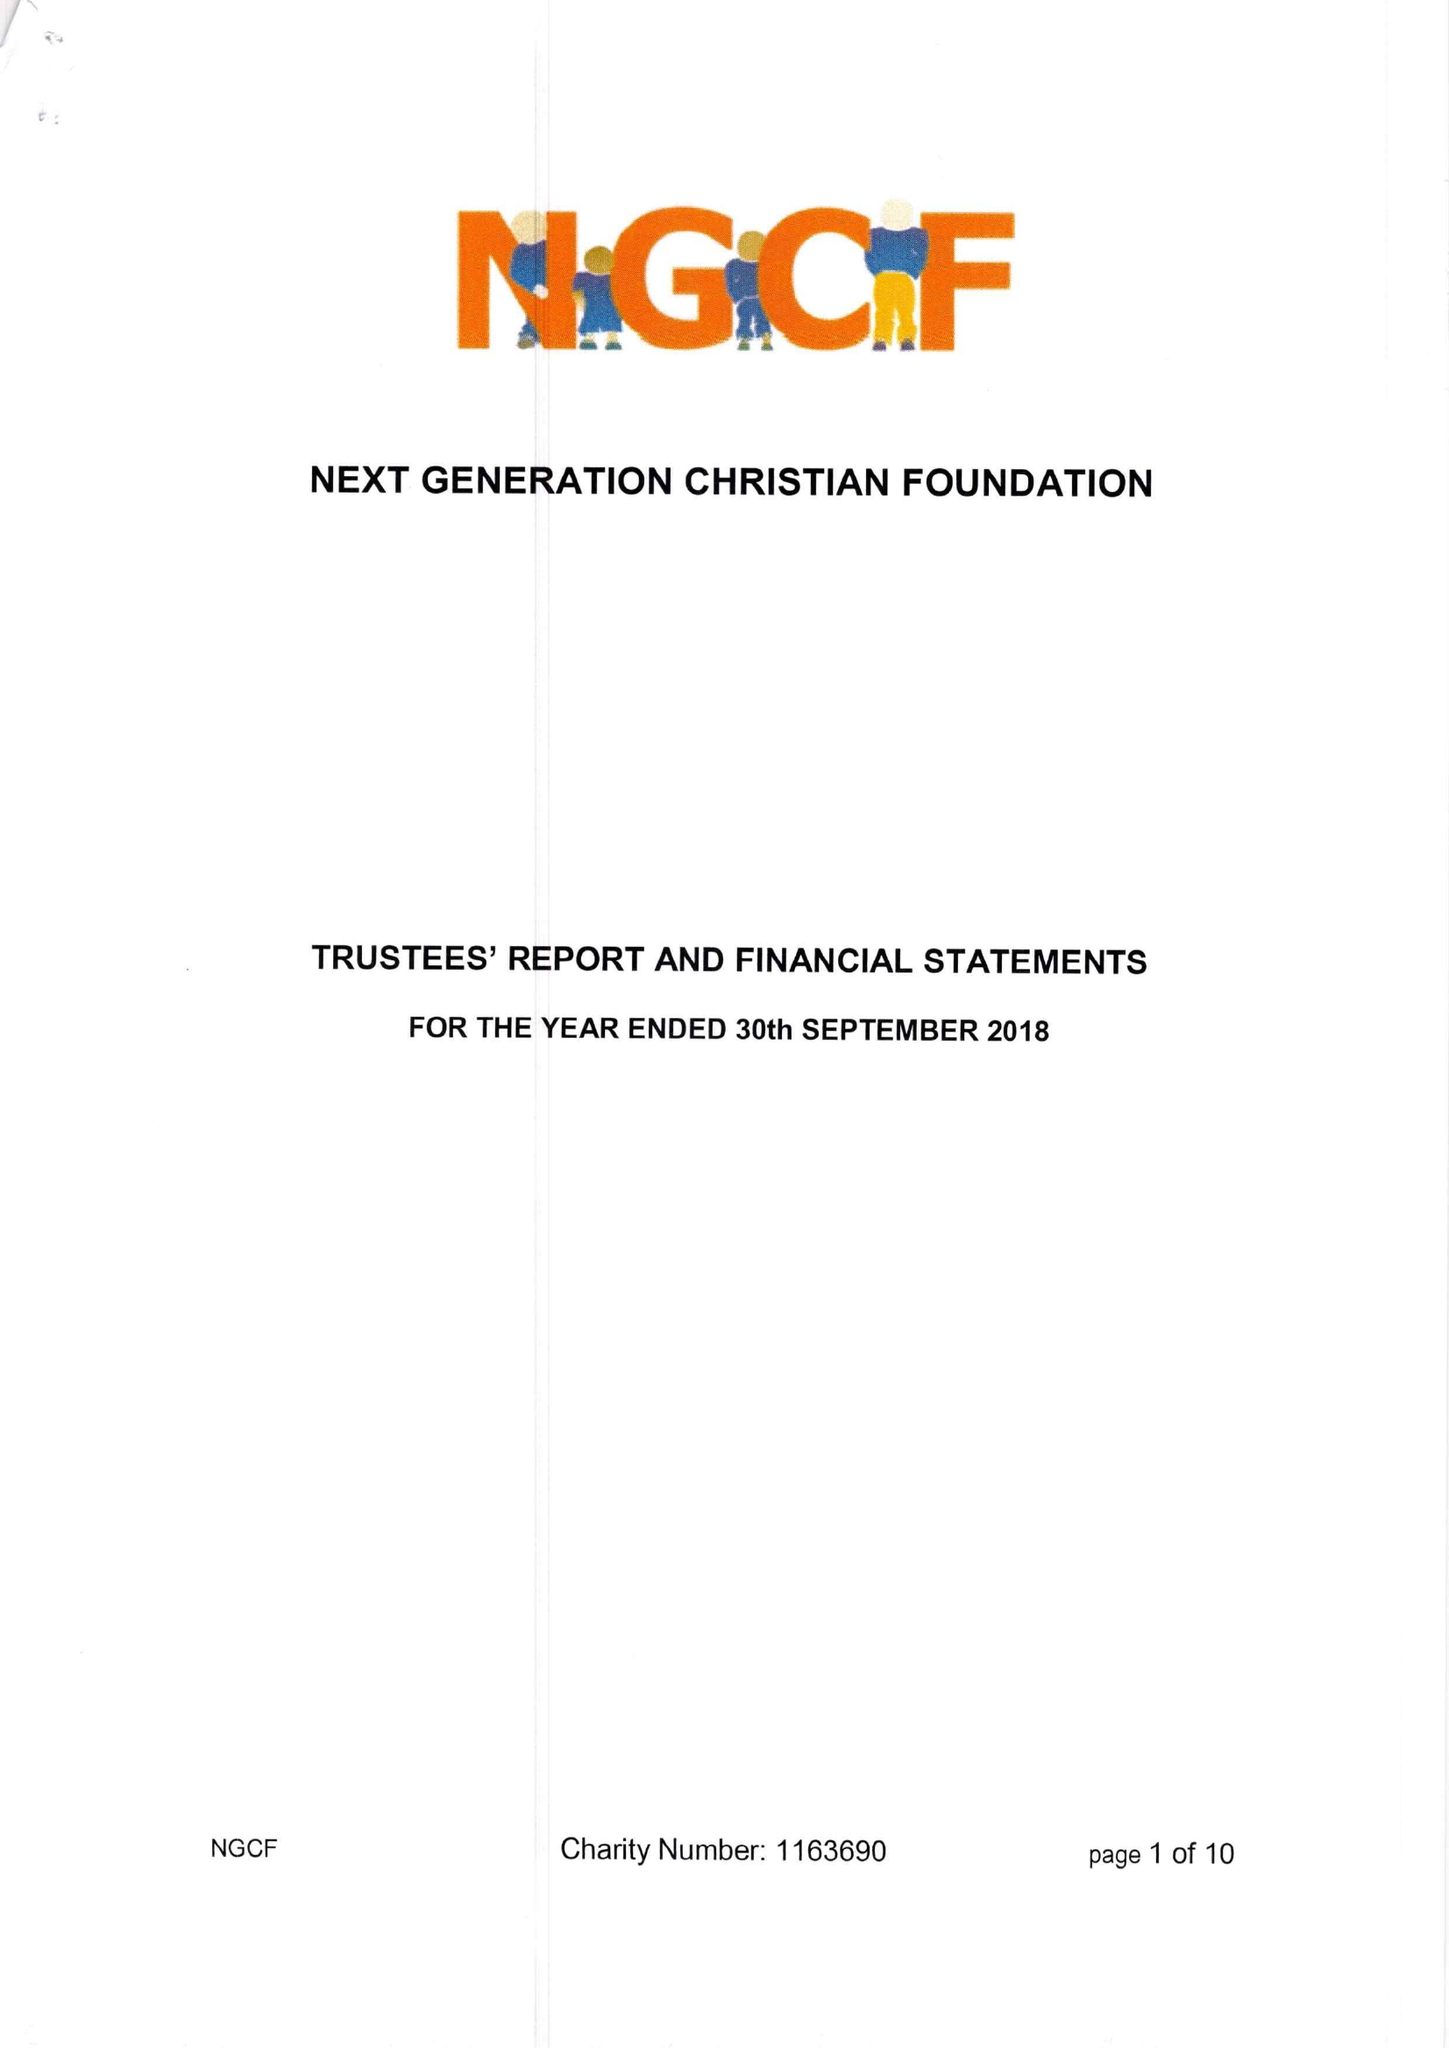What is the value for the report_date?
Answer the question using a single word or phrase. 2018-09-30 